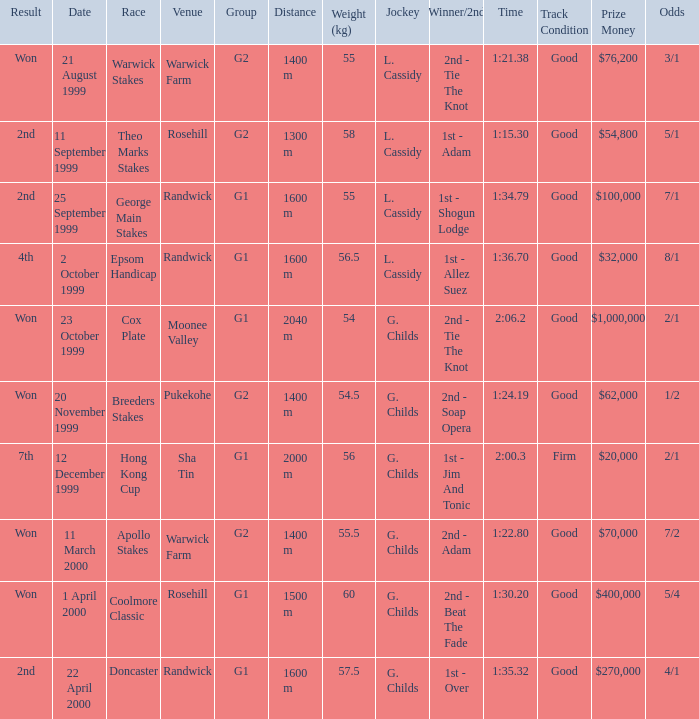List the weight for 56.5 kilograms. Epsom Handicap. 